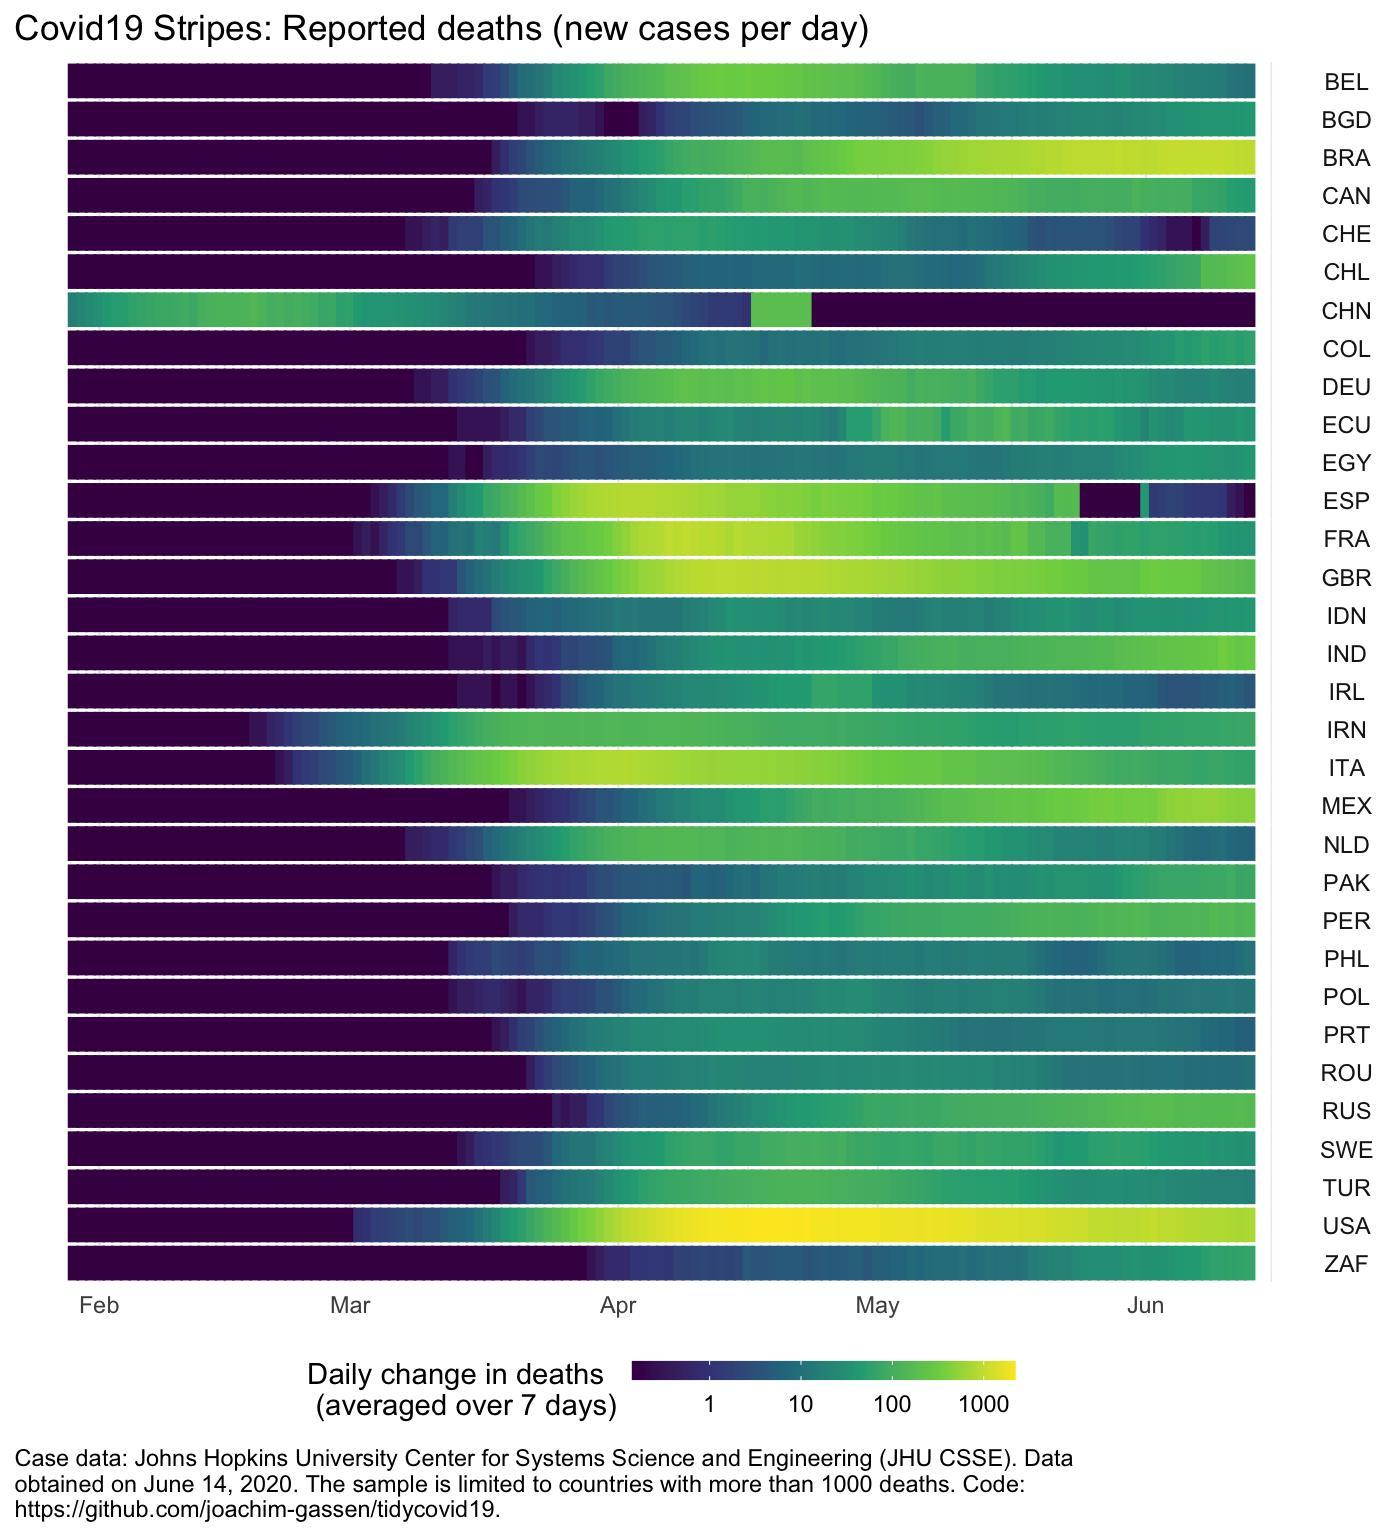Between which months were the death the highest in USA
Answer the question with a short phrase. April, May Which countries have shown an increasing trend in June BRA, MEX Which country had cases over 10 in February China After showing decrease, in which month was there a spike in cases in China followed by a decrease again April 